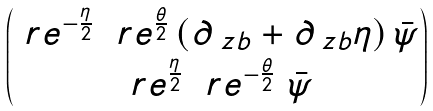<formula> <loc_0><loc_0><loc_500><loc_500>\begin{pmatrix} \ r e ^ { - \frac { \eta } { 2 } } \ \ r e ^ { \frac { \theta } { 2 } } \, ( \partial _ { \ z b } + \partial _ { \ z b } \eta ) \, { \bar { \psi } } \\ \ r e ^ { \frac { \eta } { 2 } } \ \ r e ^ { - \frac { \theta } { 2 } } \ { \bar { \psi } } \end{pmatrix}</formula> 